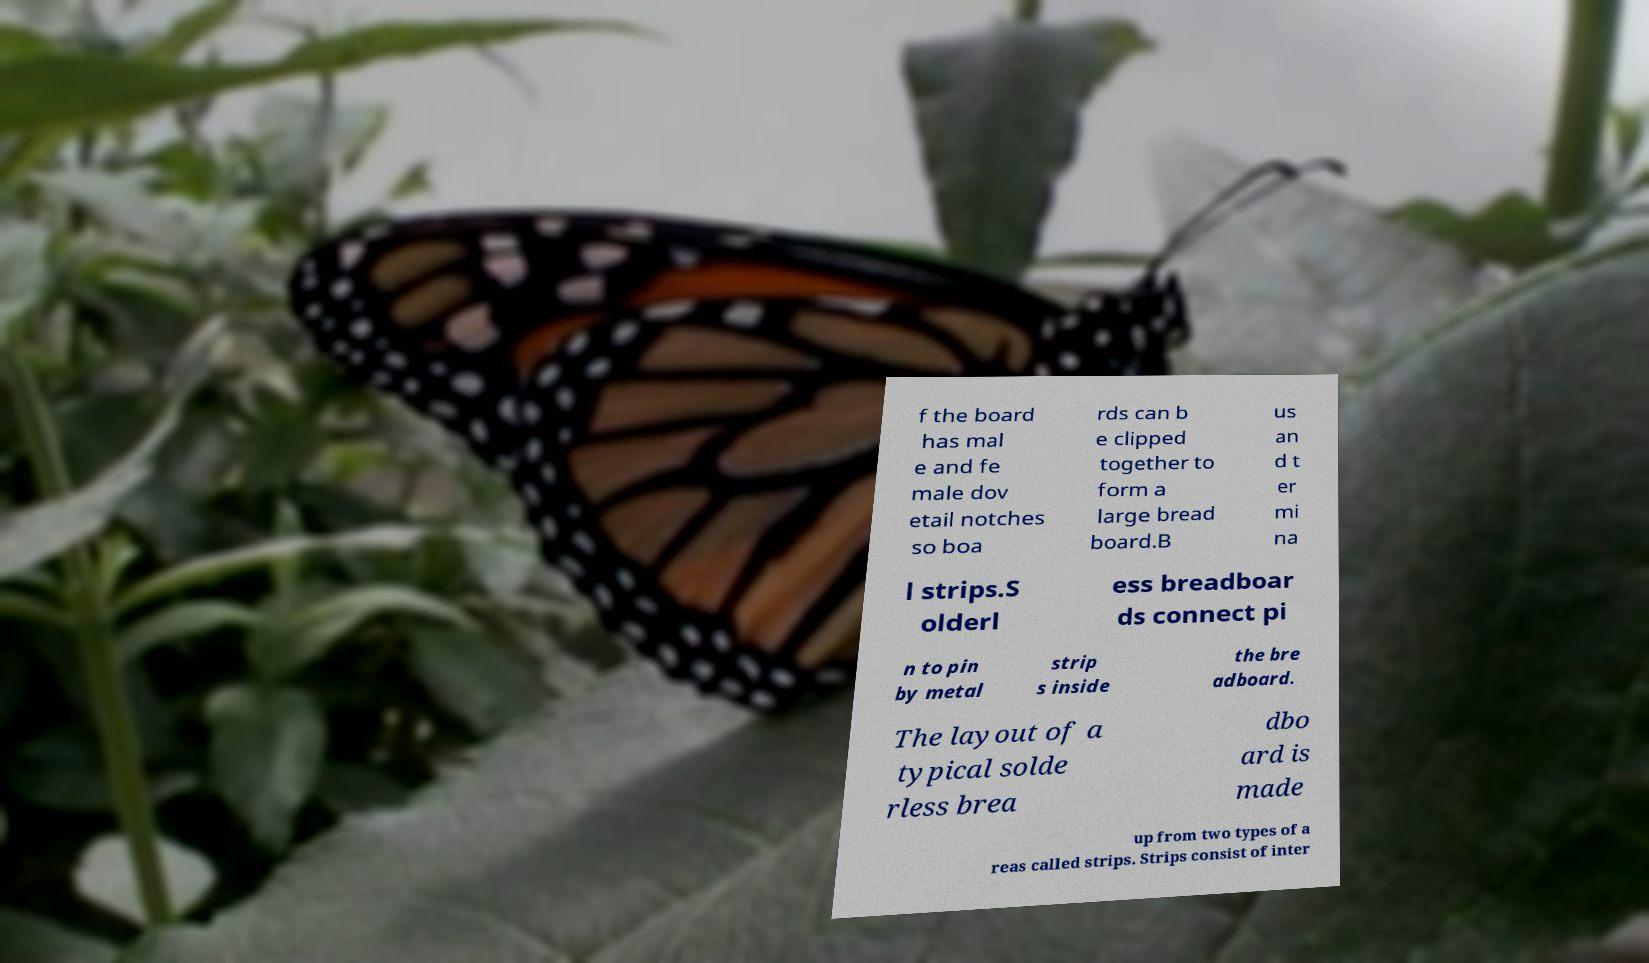I need the written content from this picture converted into text. Can you do that? f the board has mal e and fe male dov etail notches so boa rds can b e clipped together to form a large bread board.B us an d t er mi na l strips.S olderl ess breadboar ds connect pi n to pin by metal strip s inside the bre adboard. The layout of a typical solde rless brea dbo ard is made up from two types of a reas called strips. Strips consist of inter 